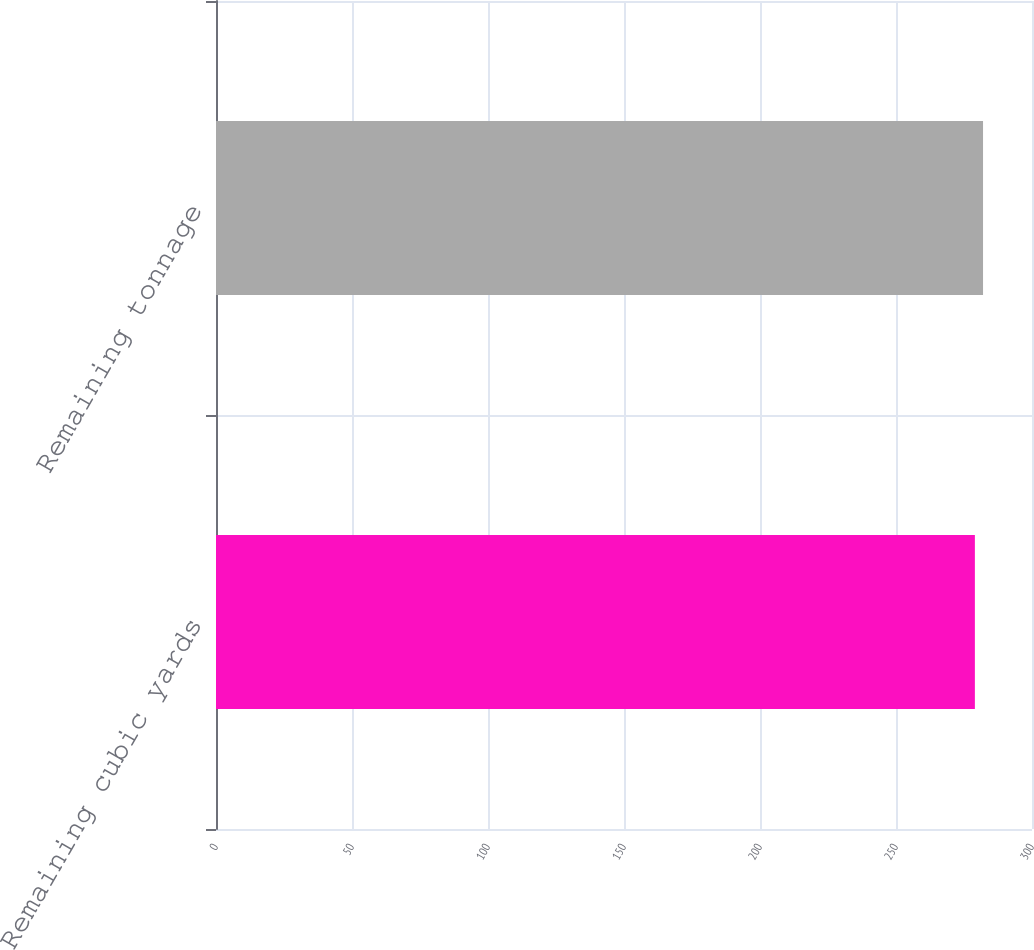Convert chart to OTSL. <chart><loc_0><loc_0><loc_500><loc_500><bar_chart><fcel>Remaining cubic yards<fcel>Remaining tonnage<nl><fcel>279<fcel>282<nl></chart> 